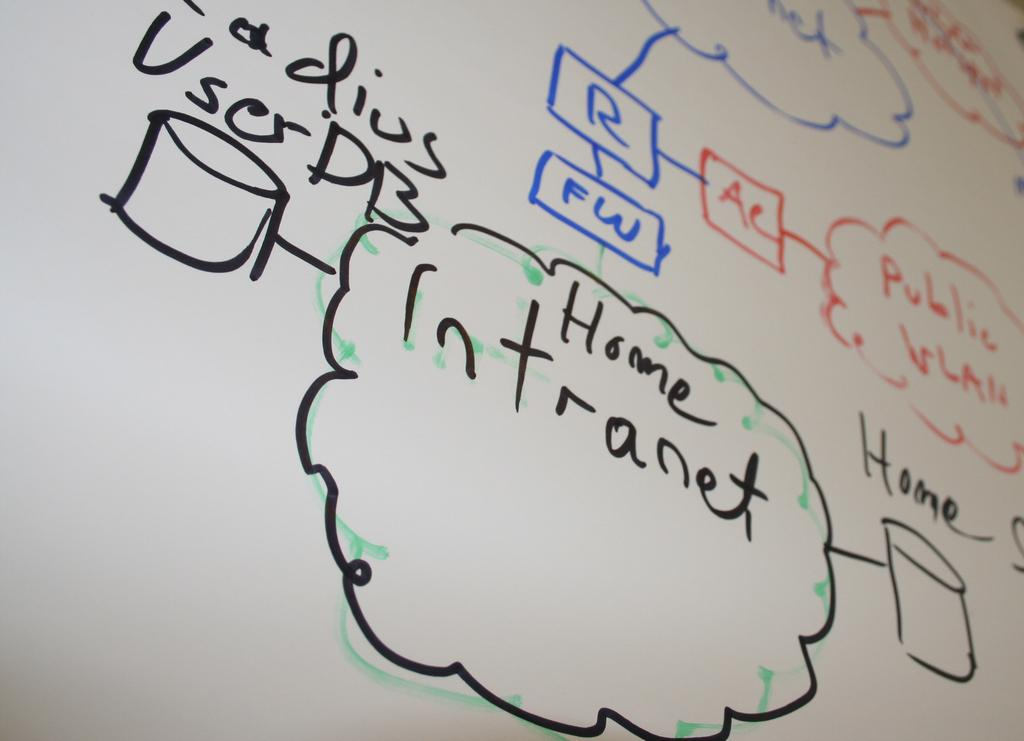<image>
Present a compact description of the photo's key features. the name intranet that is on a white board 